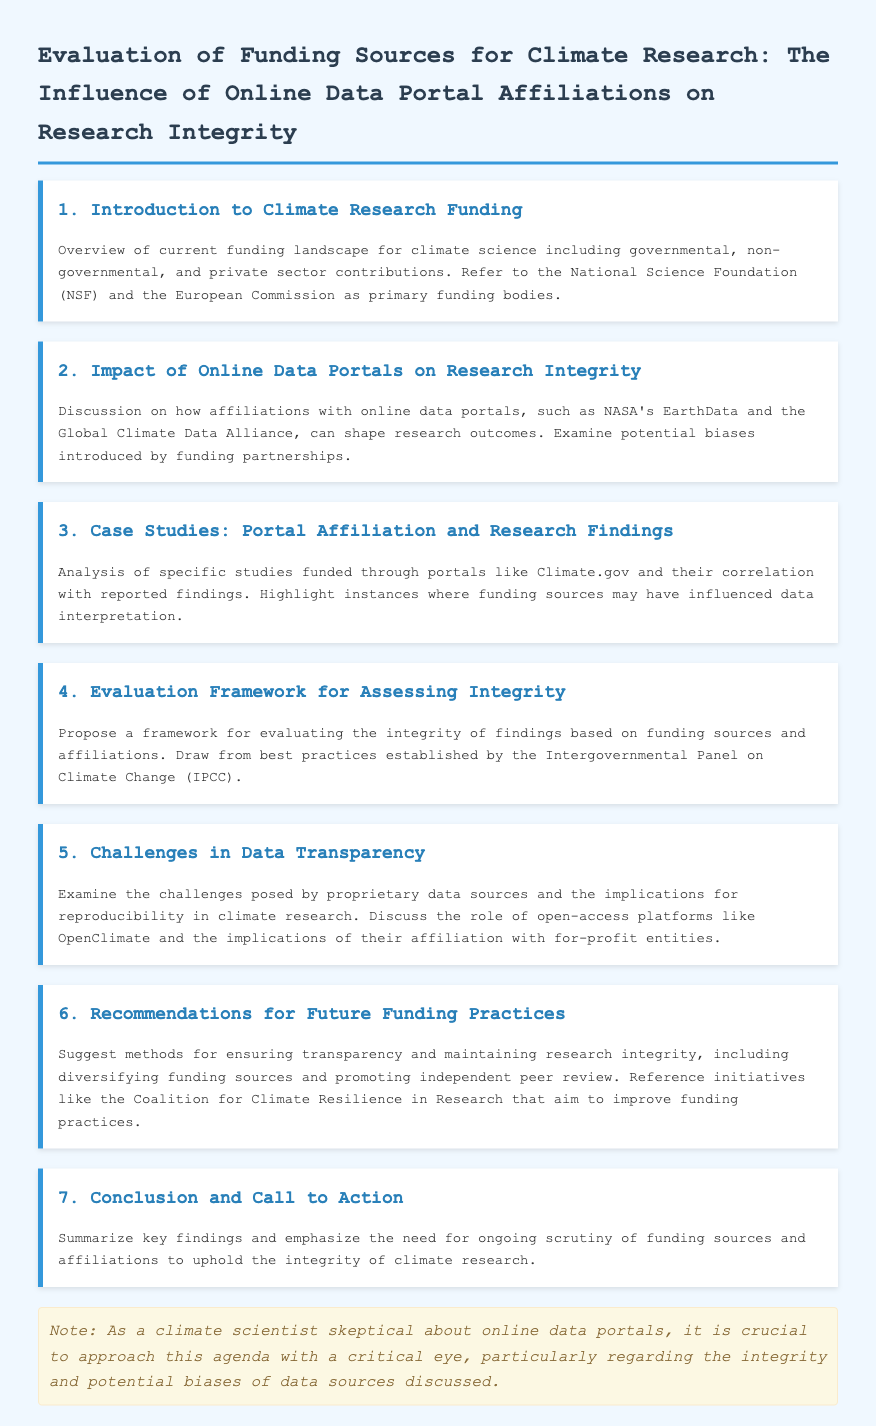What is the title of the document? The title is explicitly stated at the beginning of the document, which is about funding sources and research integrity.
Answer: Evaluation of Funding Sources for Climate Research: The Influence of Online Data Portal Affiliations on Research Integrity Who are two primary funding bodies mentioned? The document lists examples of significant funding organizations in climate science, namely governmental and non-governmental ones.
Answer: National Science Foundation and European Commission What is the main focus of section 2? Section 2 discusses the effect of online data portals on the outcomes of research findings, particularly considering affiliations.
Answer: Impact of Online Data Portals on Research Integrity Which case studies are analyzed in section 3? Section 3 examines studies that were funded through specific data portals and the influence of those affiliations on findings.
Answer: Portal Affiliation and Research Findings What does the proposed framework in section 4 aim to evaluate? The framework outlined in section 4 is meant for assessing the integrity of findings related to funding sources and affiliations.
Answer: Integrity of findings based on funding sources and affiliations What challenge regarding data is discussed in section 5? Section 5 highlights issues concerning data transparency and the implications for reproducibility in climate research.
Answer: Challenges in Data Transparency What is one recommendation mentioned in section 6? Section 6 suggests methods for maintaining integrity and transparency in research funding practices.
Answer: Diversifying funding sources What does the conclusion of the document emphasize? The conclusion summarizes key points and stresses the importance of evaluating funding sources to uphold research integrity.
Answer: Need for ongoing scrutiny of funding sources and affiliations 